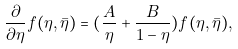<formula> <loc_0><loc_0><loc_500><loc_500>\frac { \partial } { \partial \eta } f ( \eta , \bar { \eta } ) = ( \frac { A } { \eta } + \frac { B } { 1 - \eta } ) f ( \eta , \bar { \eta } ) ,</formula> 